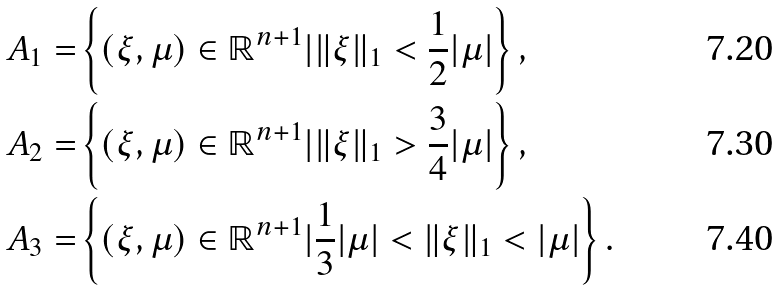Convert formula to latex. <formula><loc_0><loc_0><loc_500><loc_500>A _ { 1 } = & \left \{ ( \xi , \mu ) \in \mathbb { R } ^ { n + 1 } | \| \xi \| _ { 1 } < \frac { 1 } { 2 } | \mu | \right \} , \\ A _ { 2 } = & \left \{ ( \xi , \mu ) \in \mathbb { R } ^ { n + 1 } | \| \xi \| _ { 1 } > \frac { 3 } { 4 } | \mu | \right \} , \\ A _ { 3 } = & \left \{ ( \xi , \mu ) \in \mathbb { R } ^ { n + 1 } | \frac { 1 } { 3 } | \mu | < \| \xi \| _ { 1 } < | \mu | \right \} .</formula> 